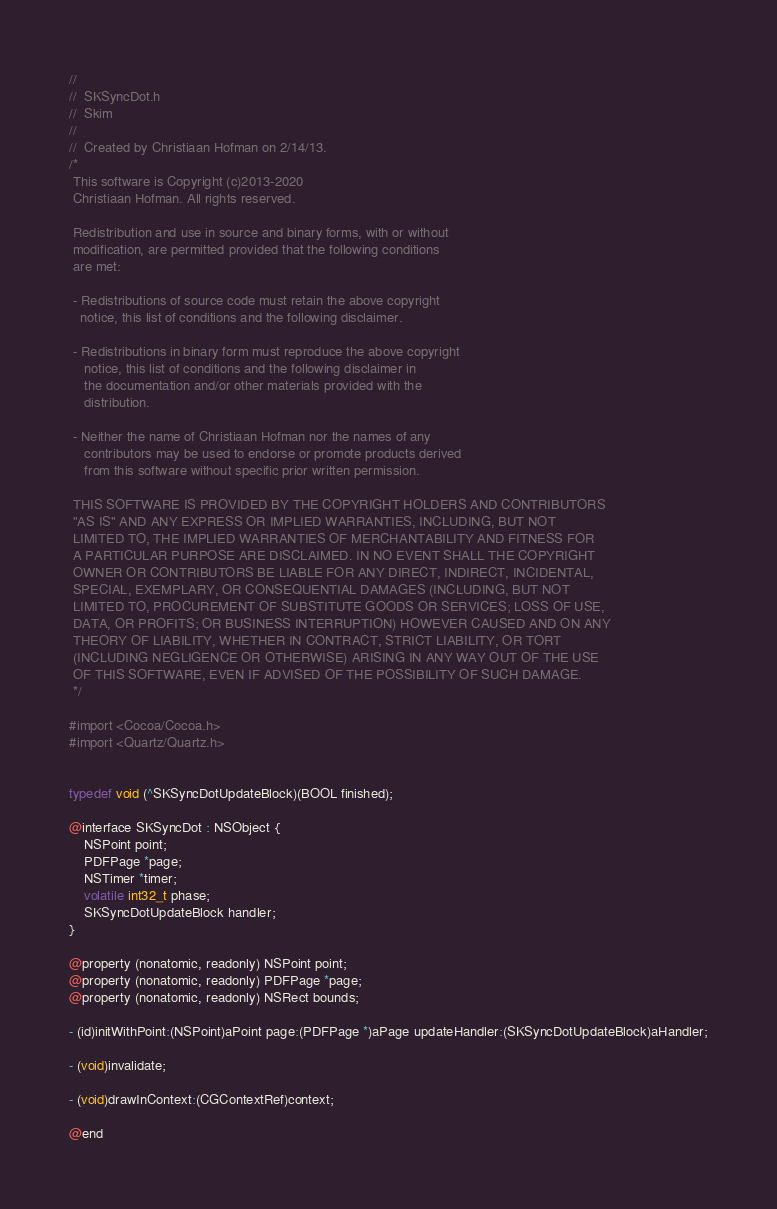<code> <loc_0><loc_0><loc_500><loc_500><_C_>//
//  SKSyncDot.h
//  Skim
//
//  Created by Christiaan Hofman on 2/14/13.
/*
 This software is Copyright (c)2013-2020
 Christiaan Hofman. All rights reserved.

 Redistribution and use in source and binary forms, with or without
 modification, are permitted provided that the following conditions
 are met:

 - Redistributions of source code must retain the above copyright
   notice, this list of conditions and the following disclaimer.

 - Redistributions in binary form must reproduce the above copyright
    notice, this list of conditions and the following disclaimer in
    the documentation and/or other materials provided with the
    distribution.

 - Neither the name of Christiaan Hofman nor the names of any
    contributors may be used to endorse or promote products derived
    from this software without specific prior written permission.

 THIS SOFTWARE IS PROVIDED BY THE COPYRIGHT HOLDERS AND CONTRIBUTORS
 "AS IS" AND ANY EXPRESS OR IMPLIED WARRANTIES, INCLUDING, BUT NOT
 LIMITED TO, THE IMPLIED WARRANTIES OF MERCHANTABILITY AND FITNESS FOR
 A PARTICULAR PURPOSE ARE DISCLAIMED. IN NO EVENT SHALL THE COPYRIGHT
 OWNER OR CONTRIBUTORS BE LIABLE FOR ANY DIRECT, INDIRECT, INCIDENTAL,
 SPECIAL, EXEMPLARY, OR CONSEQUENTIAL DAMAGES (INCLUDING, BUT NOT
 LIMITED TO, PROCUREMENT OF SUBSTITUTE GOODS OR SERVICES; LOSS OF USE,
 DATA, OR PROFITS; OR BUSINESS INTERRUPTION) HOWEVER CAUSED AND ON ANY
 THEORY OF LIABILITY, WHETHER IN CONTRACT, STRICT LIABILITY, OR TORT
 (INCLUDING NEGLIGENCE OR OTHERWISE) ARISING IN ANY WAY OUT OF THE USE
 OF THIS SOFTWARE, EVEN IF ADVISED OF THE POSSIBILITY OF SUCH DAMAGE.
 */

#import <Cocoa/Cocoa.h>
#import <Quartz/Quartz.h>


typedef void (^SKSyncDotUpdateBlock)(BOOL finished);

@interface SKSyncDot : NSObject {
    NSPoint point;
    PDFPage *page;
    NSTimer *timer;
    volatile int32_t phase;
    SKSyncDotUpdateBlock handler;
}

@property (nonatomic, readonly) NSPoint point;
@property (nonatomic, readonly) PDFPage *page;
@property (nonatomic, readonly) NSRect bounds;

- (id)initWithPoint:(NSPoint)aPoint page:(PDFPage *)aPage updateHandler:(SKSyncDotUpdateBlock)aHandler;

- (void)invalidate;

- (void)drawInContext:(CGContextRef)context;

@end
</code> 